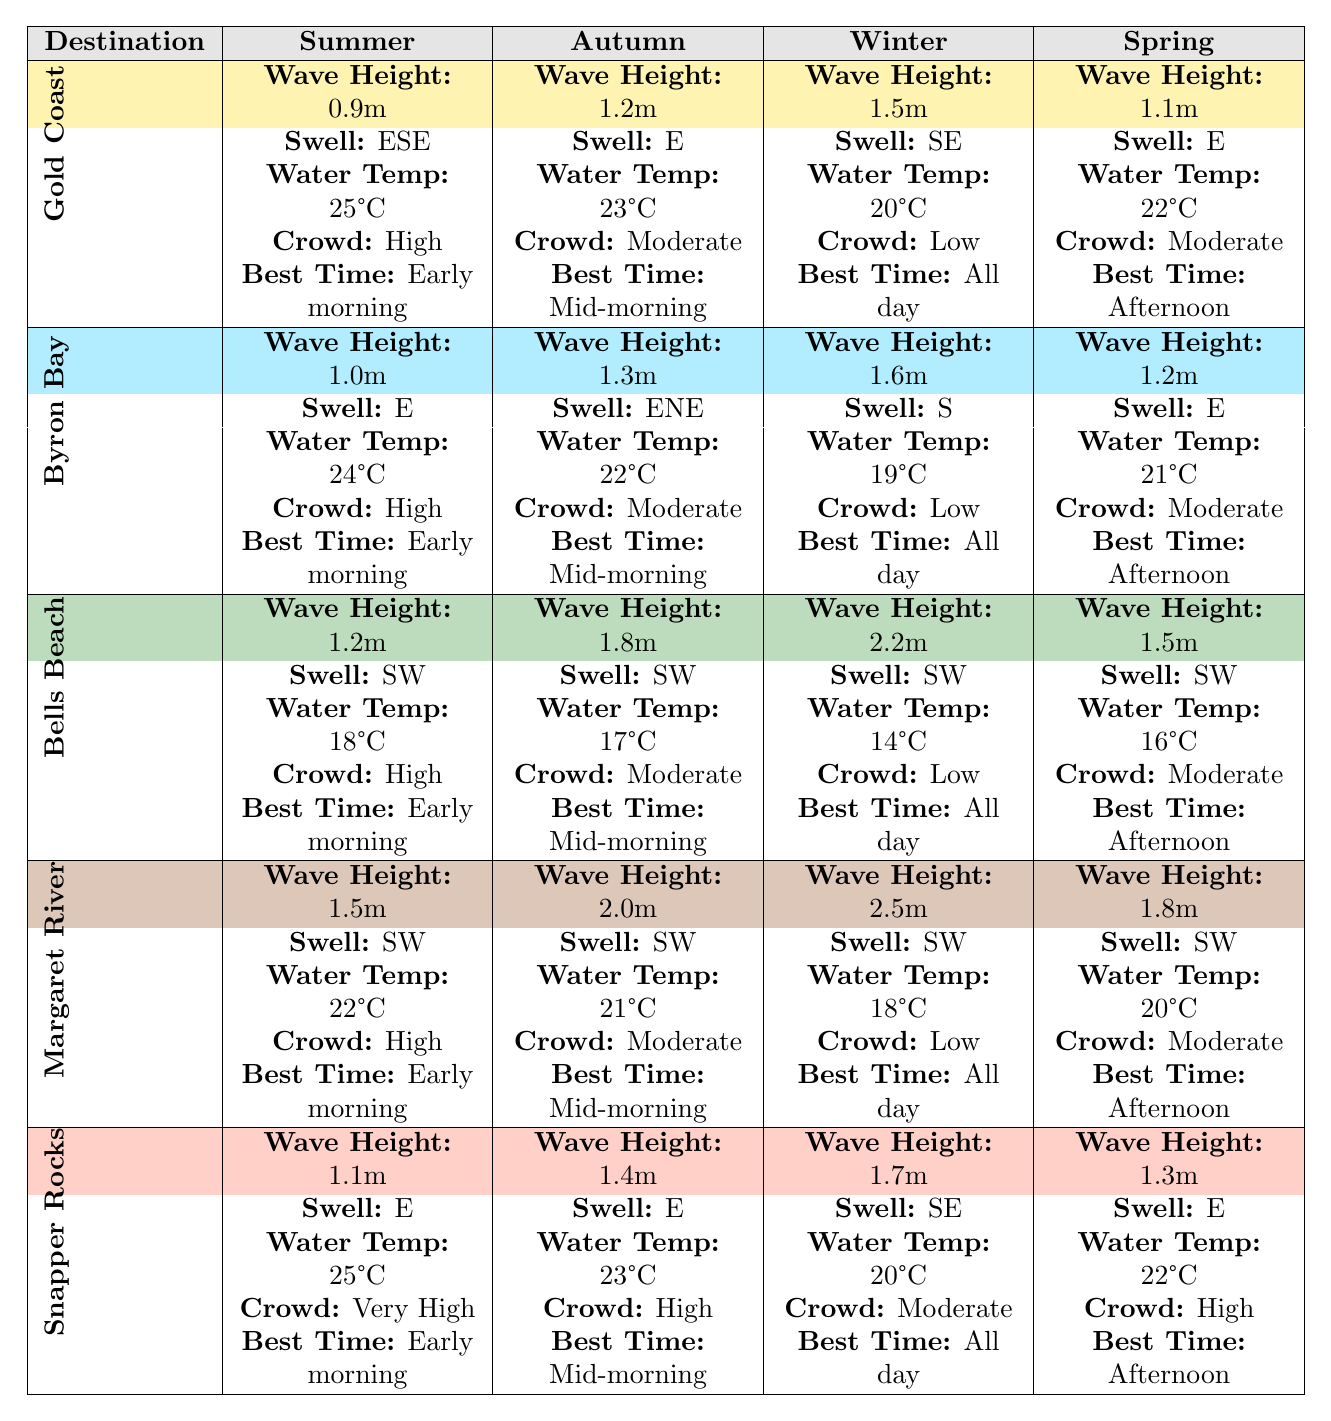What's the average wave height in winter at Margaret River? The wave height in winter at Margaret River is 2.5 meters, as stated in the table.
Answer: 2.5 meters Which destination has the highest crowd level in summer? Snapper Rocks has the highest crowd level in summer, labeled as "Very High".
Answer: Snapper Rocks What is the swell direction in autumn for Bells Beach? In autumn, the swell direction for Bells Beach is "SW", as indicated in the table.
Answer: SW Which season has the lowest average wave height in Byron Bay? In Byron Bay, summer has the lowest average wave height of 1.0 meters compared to other seasons.
Answer: Summer Is the water temperature in winter lower at Byron Bay than at Snapper Rocks? Yes, the water temperature in winter at Byron Bay is 19 degrees Celsius, while at Snapper Rocks, it is 20 degrees Celsius.
Answer: Yes What season offers the best time to surf in autumn across all destinations? The best time to surf in autumn is "Mid-morning" for all listed destinations, based on the table data.
Answer: Mid-morning During which season does Bells Beach experience the highest average wave height? Bells Beach experiences the highest average wave height in winter, which is 2.2 meters.
Answer: Winter What is the average wave height across all seasons for Gold Coast? The average wave height for Gold Coast across all seasons is (0.9 + 1.2 + 1.5 + 1.1) / 4 = 1.175 meters.
Answer: 1.175 meters Do both Byron Bay and Snapper Rocks have the same swell direction in spring? No, in spring, Byron Bay has a swell direction of "E", while Snapper Rocks also has a swell direction of "E", so they do match.
Answer: Yes What percentage of the seasons in which Margaret River has a wave height over 2.0 meters? Margaret River has a wave height over 2.0 meters only in winter (2.5m), which is 1 out of 4 seasons, meaning it’s 25%.
Answer: 25% 